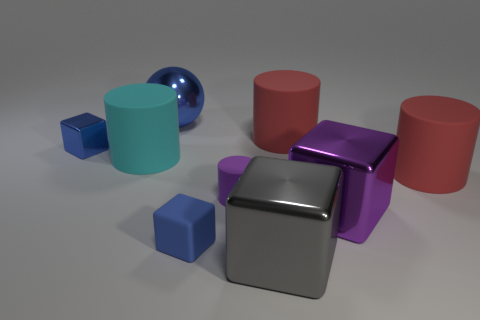Subtract 1 blocks. How many blocks are left? 3 Add 1 small purple metal spheres. How many objects exist? 10 Subtract all balls. How many objects are left? 8 Add 1 red cylinders. How many red cylinders exist? 3 Subtract 0 cyan balls. How many objects are left? 9 Subtract all large cyan cylinders. Subtract all blue blocks. How many objects are left? 6 Add 9 big gray shiny things. How many big gray shiny things are left? 10 